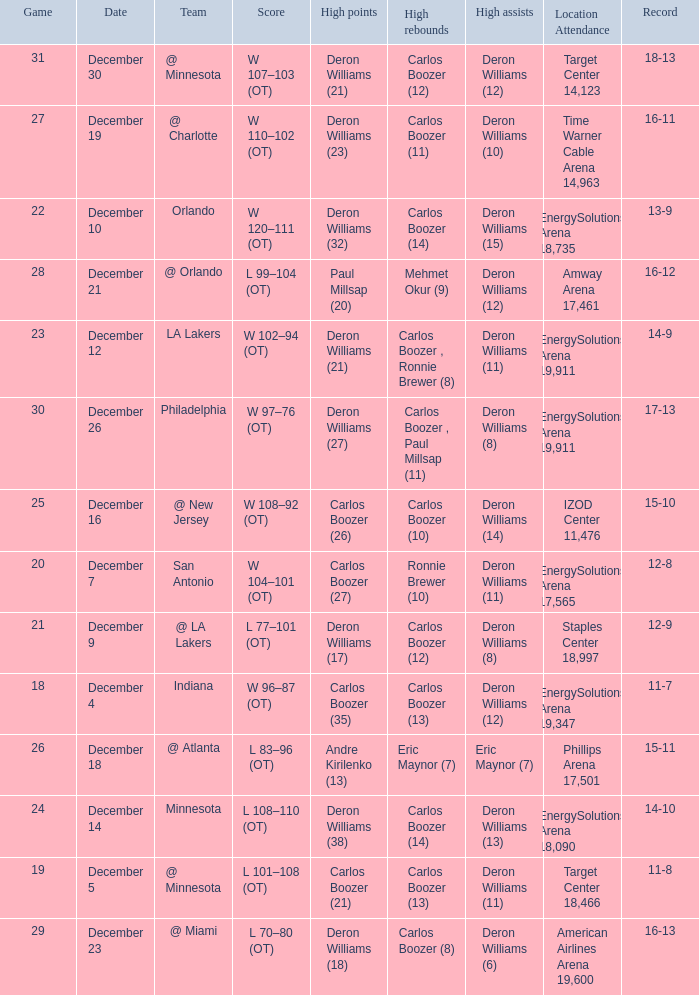When was the game in which Deron Williams (13) did the high assists played? December 14. 